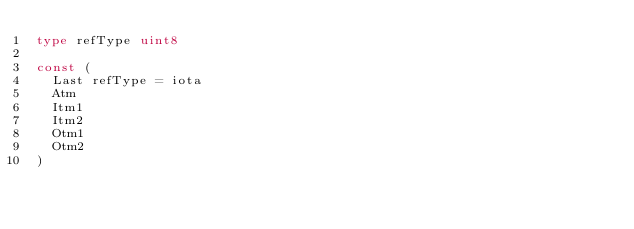Convert code to text. <code><loc_0><loc_0><loc_500><loc_500><_Go_>type refType uint8

const (
	Last refType = iota
	Atm
	Itm1
	Itm2
	Otm1
	Otm2
)
</code> 